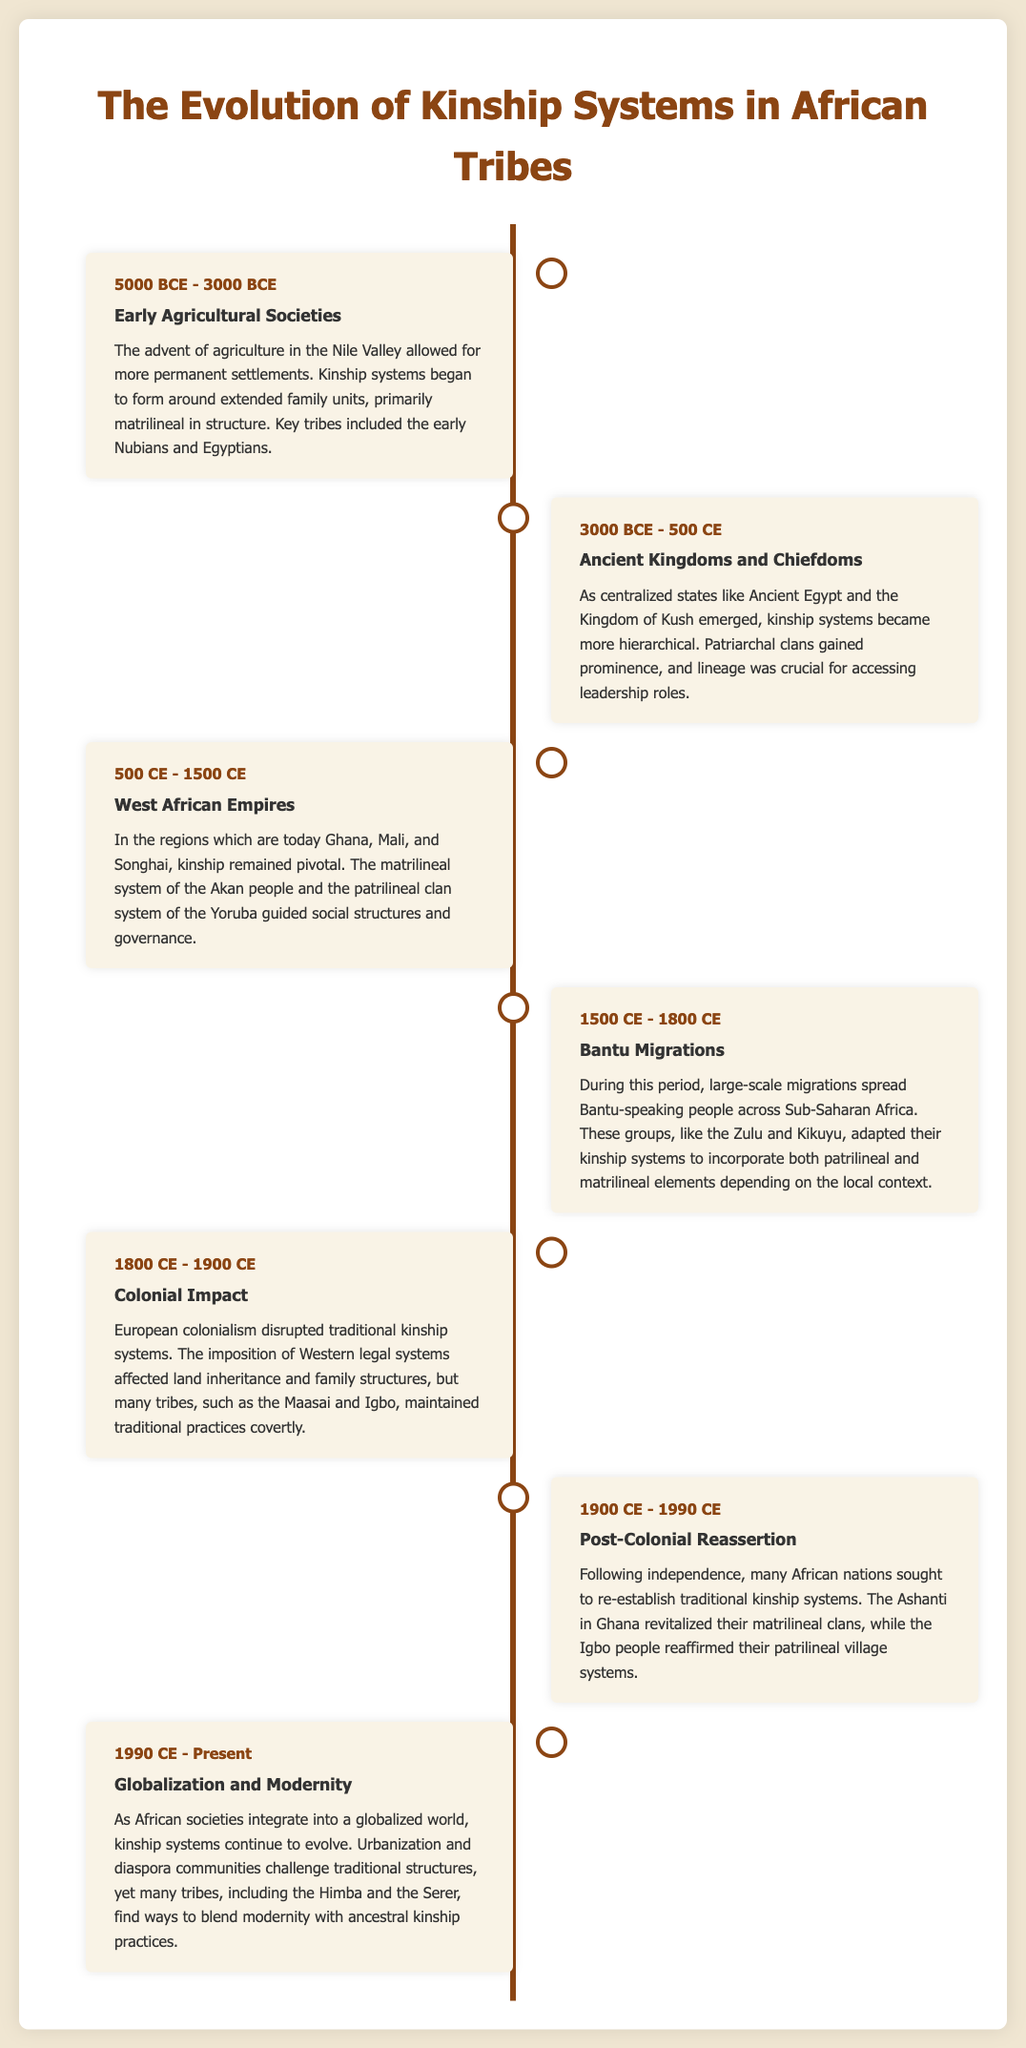What time period is associated with early agricultural societies? The time period for early agricultural societies is highlighted in the document as 5000 BCE - 3000 BCE.
Answer: 5000 BCE - 3000 BCE Which kinship system became more hierarchical during ancient kingdoms and chiefdoms? The document specifies that patriarchal clans gained prominence during the period of Ancient Kingdoms and Chiefdoms (3000 BCE - 500 CE).
Answer: Patriarchal What major migration influenced kinship systems between 1500 CE and 1800 CE? The document indicates that the Bantu migrations were significant during this period, affecting kinship systems across Sub-Saharan Africa.
Answer: Bantu migrations Which tribe revitalized their matrilineal clans after post-colonialism? According to the document, the Ashanti in Ghana sought to re-establish their traditional matrilineal clans.
Answer: Ashanti What impact did colonialism have on kinship systems? The document mentions that European colonialism disrupted traditional kinship systems and affected land inheritance.
Answer: Disruption What is the current period's influence on kinship systems as stated in the document? The document highlights that globalization and urbanization are major influences on the evolution of kinship systems today.
Answer: Globalization Which tribe is mentioned as maintaining traditional practices covertly during colonial times? The Maasai are specifically mentioned in the document as maintaining traditional practices despite colonial influences.
Answer: Maasai What do the Himba and Serer tribes represent in the context of modern kinship systems? The Himba and Serer tribes exemplify how some tribes blend modernity with ancestral kinship practices.
Answer: Blending modernity 